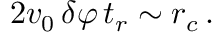Convert formula to latex. <formula><loc_0><loc_0><loc_500><loc_500>2 v _ { 0 } \, \delta \varphi \, t _ { r } \sim r _ { c } \, .</formula> 